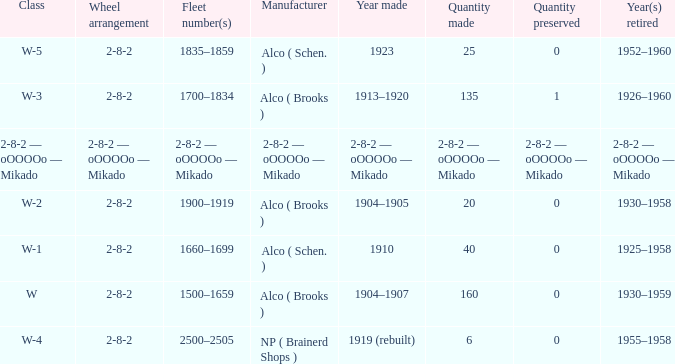What is the conserved amount for a locomotive with a value of 6? 0.0. 